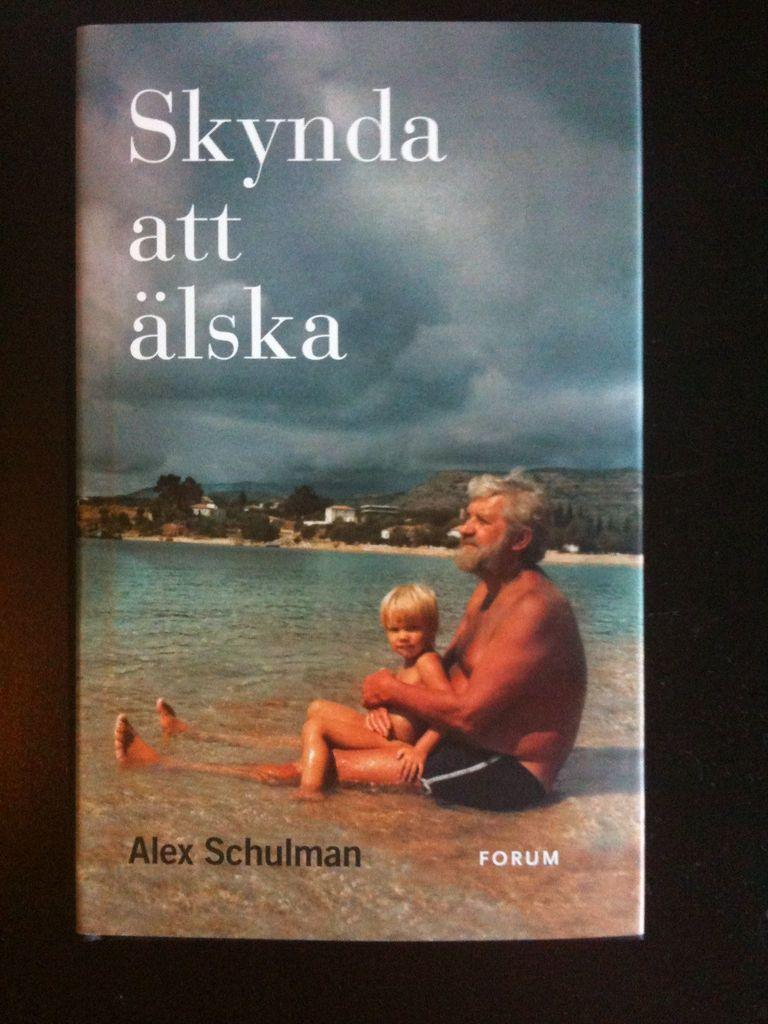<image>
Create a compact narrative representing the image presented. A foreign language book cover that reads Skynda att alska by Alex Schulman. 